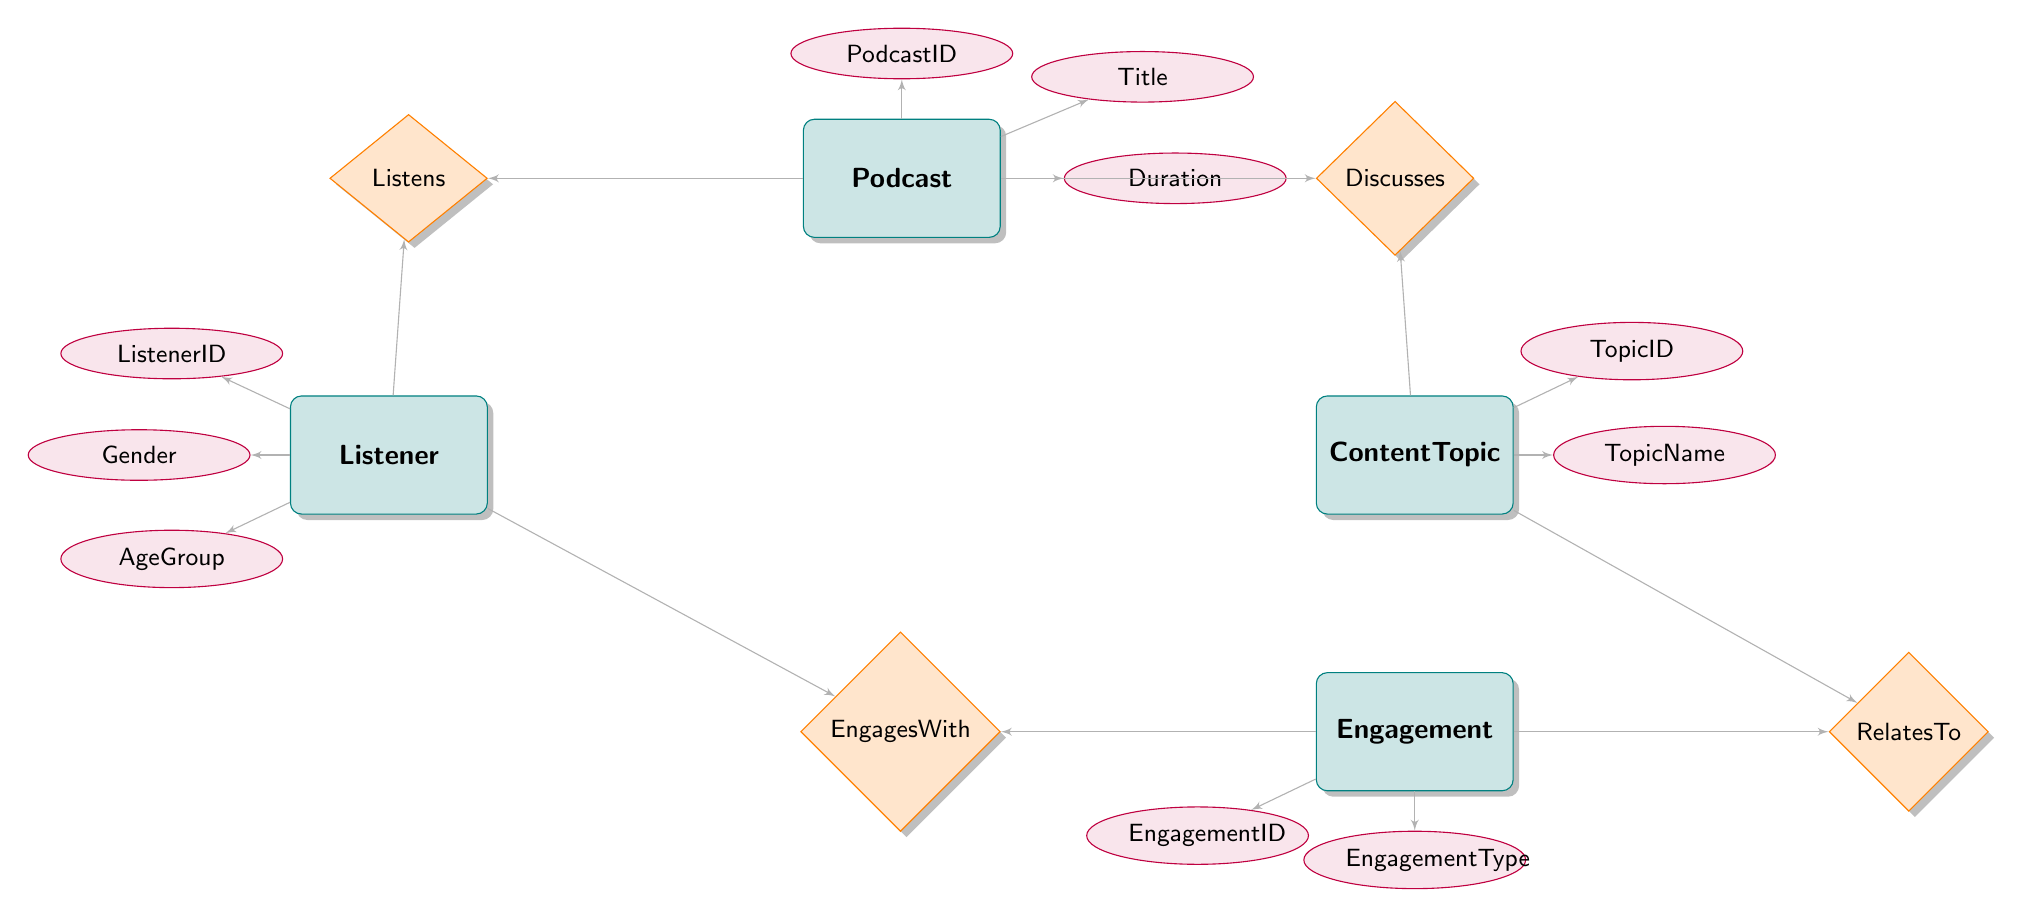What entities are present in the diagram? The diagram displays four entities: Podcast, ContentTopic, Listener, and Engagement. Each node represents a unique type of data in the Entity Relationship Diagram.
Answer: Podcast, ContentTopic, Listener, Engagement How many relationships are defined in the diagram? There are four relationships in the diagram: Discusses, Listens, EngagesWith, and RelatesTo, connecting the entities in specific ways.
Answer: 4 What attribute is associated with the Podcast entity? The Podcast entity has three attributes that describe it: PodcastID, Title, and Duration, providing details about each podcast episode.
Answer: PodcastID, Title, Duration Which entities are involved in the Discusses relationship? The Discusses relationship involves two entities: Podcast and ContentTopic, indicating that a specific podcast discusses certain topics.
Answer: Podcast, ContentTopic What attributes are associated with the Listener entity? The Listener entity includes three attributes: ListenerID, Gender, and AgeGroup, which characterize each listener's demographic information.
Answer: ListenerID, Gender, AgeGroup Which entity is related to the Engagement entity through the EngagesWith relationship? The EngagesWith relationship connects the Listener entity with the Engagement entity, showing the interaction of listeners with various engagement activities.
Answer: Listener What type of relationship connects ContentTopic and Engagement? The relationship that connects ContentTopic and Engagement is called RelatesTo, indicating how specific content topics relate to different forms of audience engagement.
Answer: RelatesTo What is the primary key of the Engagement entity? The primary key for the Engagement entity is EngagementID, which uniquely identifies each instance of engagement recorded in the system.
Answer: EngagementID How does the Listens relationship capture listener interaction? The Listens relationship captures listener interaction by linking the Listener entity and the Podcast entity, including attributes for Rating and ListeningDuration to quantify the listener's experience.
Answer: Listener, Podcast 